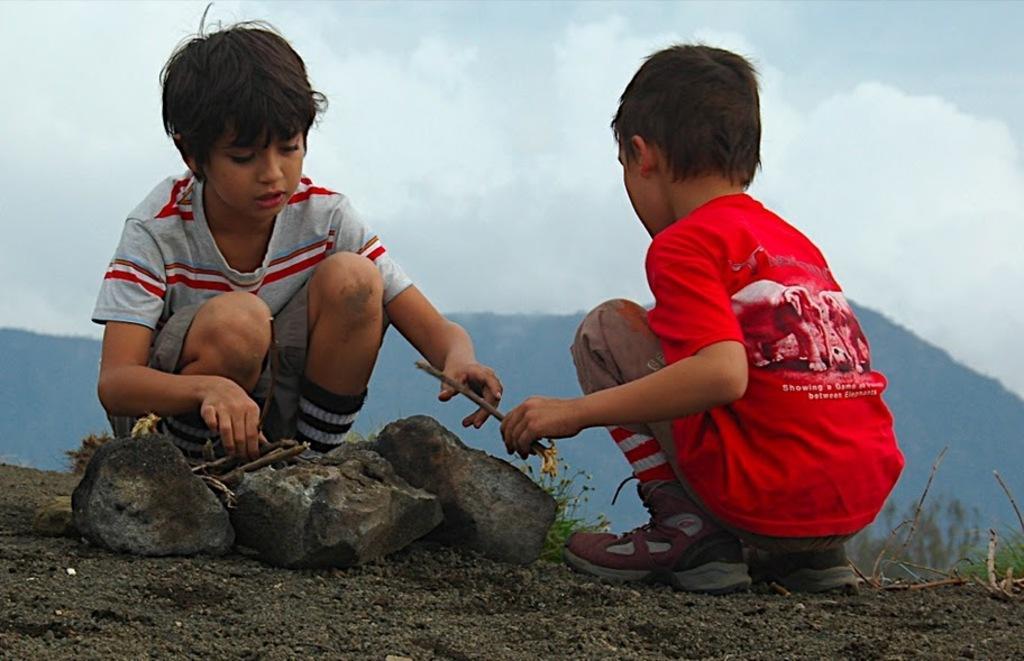Can you describe this image briefly? In this image we can see two boys sitting and holding twigs. At the bottom there are rocks. In the background there are hills and sky. 